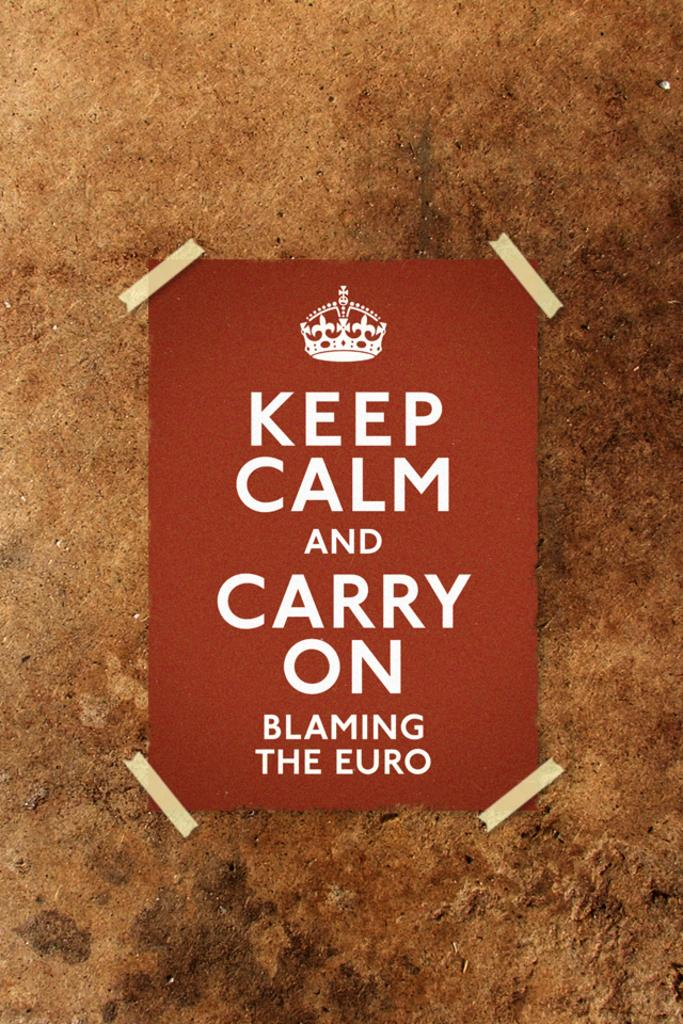<image>
Relay a brief, clear account of the picture shown. A poster that says Keep Calm and Carry On blaming the Euro is taped to ta wall 